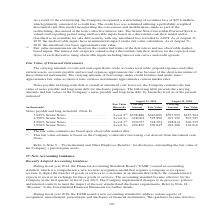According to Jabil Circuit's financial document, What were the Level 3 fair value estimates based on? the Company’s indicative borrowing cost derived from discounted cash flows.. The document states: "ket data. (2) This fair value estimate is based on the Company’s indicative borrowing cost derived from discounted cash flows...." Also, What were the Level 2 fair value estimates based on? observable market data.. The document states: "(1) The fair value estimates are based upon observable market data. (2) This fair value estimate is based on the Company’s indicative borrowing cost d..." Also, What was the carrying amount in the 5.625% Senior Notes in 2019? According to the financial document, $398,886 (in thousands). The relevant text states: "m debt: (Note 8) 5.625% Senior Notes . Level 2 (1) $398,886 $416,000 $397,995 $415,704 4.700% Senior Notes . Level 2 (1) 498,004 525,890 497,350 503,545 4.900%..." Also, can you calculate: What was the change in the fair value for the 4.700% Senior Notes between 2018 and 2019? Based on the calculation: 525,890-503,545, the result is 22345 (in thousands). This is based on the information: "415,704 4.700% Senior Notes . Level 2 (1) 498,004 525,890 497,350 503,545 4.900% Senior Notes . Level 3 (2) 299,057 318,704 298,814 306,535 3.950% Senior Not enior Notes . Level 2 (1) 498,004 525,890 ..." The key data points involved are: 503,545, 525,890. Also, can you calculate: What was the change in the fair value for the 3.950% Senior Notes between 2018 and 2019? Based on the calculation: 509,845-476,010, the result is 33835 (in thousands). This is based on the information: "306,535 3.950% Senior Notes . Level 2 (1) 494,825 509,845 494,208 476,010 enior Notes . Level 2 (1) 494,825 509,845 494,208 476,010..." The key data points involved are: 476,010, 509,845. Also, can you calculate: What was the percentage change in the carrying amount for the 4.900% Senior Notes between 2018 and 2019? To answer this question, I need to perform calculations using the financial data. The calculation is: (299,057-298,814)/298,814, which equals 0.08 (percentage). This is based on the information: "4.900% Senior Notes . Level 3 (2) 299,057 318,704 298,814 306,535 3.950% Senior Notes . Level 2 (1) 494,825 509,845 494,208 476,010 497,350 503,545 4.900% Senior Notes . Level 3 (2) 299,057 318,704 29..." The key data points involved are: 298,814, 299,057. 